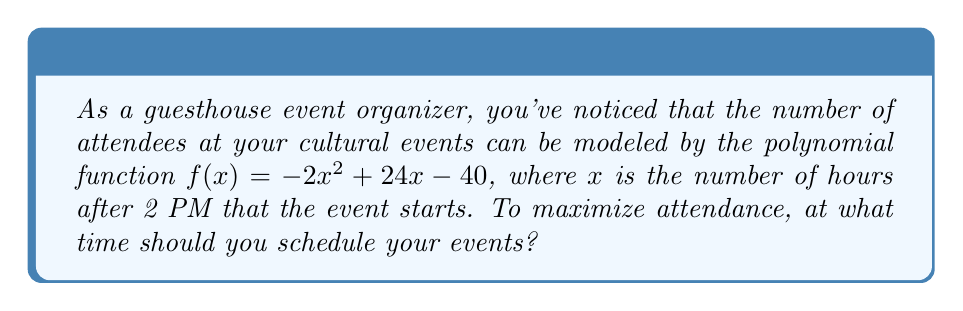Show me your answer to this math problem. To find the optimal time for maximum attendance, we need to find the maximum point of the given polynomial function.

1) The function $f(x) = -2x^2 + 24x - 40$ is a quadratic function, which forms a parabola.

2) For a quadratic function in the form $f(x) = ax^2 + bx + c$, the x-coordinate of the vertex (which gives the maximum or minimum point) is given by $x = -\frac{b}{2a}$.

3) In this case, $a = -2$, $b = 24$, and $c = -40$.

4) Substituting these values:

   $x = -\frac{24}{2(-2)} = -\frac{24}{-4} = 6$

5) This means the maximum point occurs when $x = 6$, which represents 6 hours after 2 PM.

6) To convert this to actual time:
   2 PM + 6 hours = 8 PM

Therefore, to maximize attendance, you should schedule your events at 8 PM.
Answer: 8 PM 